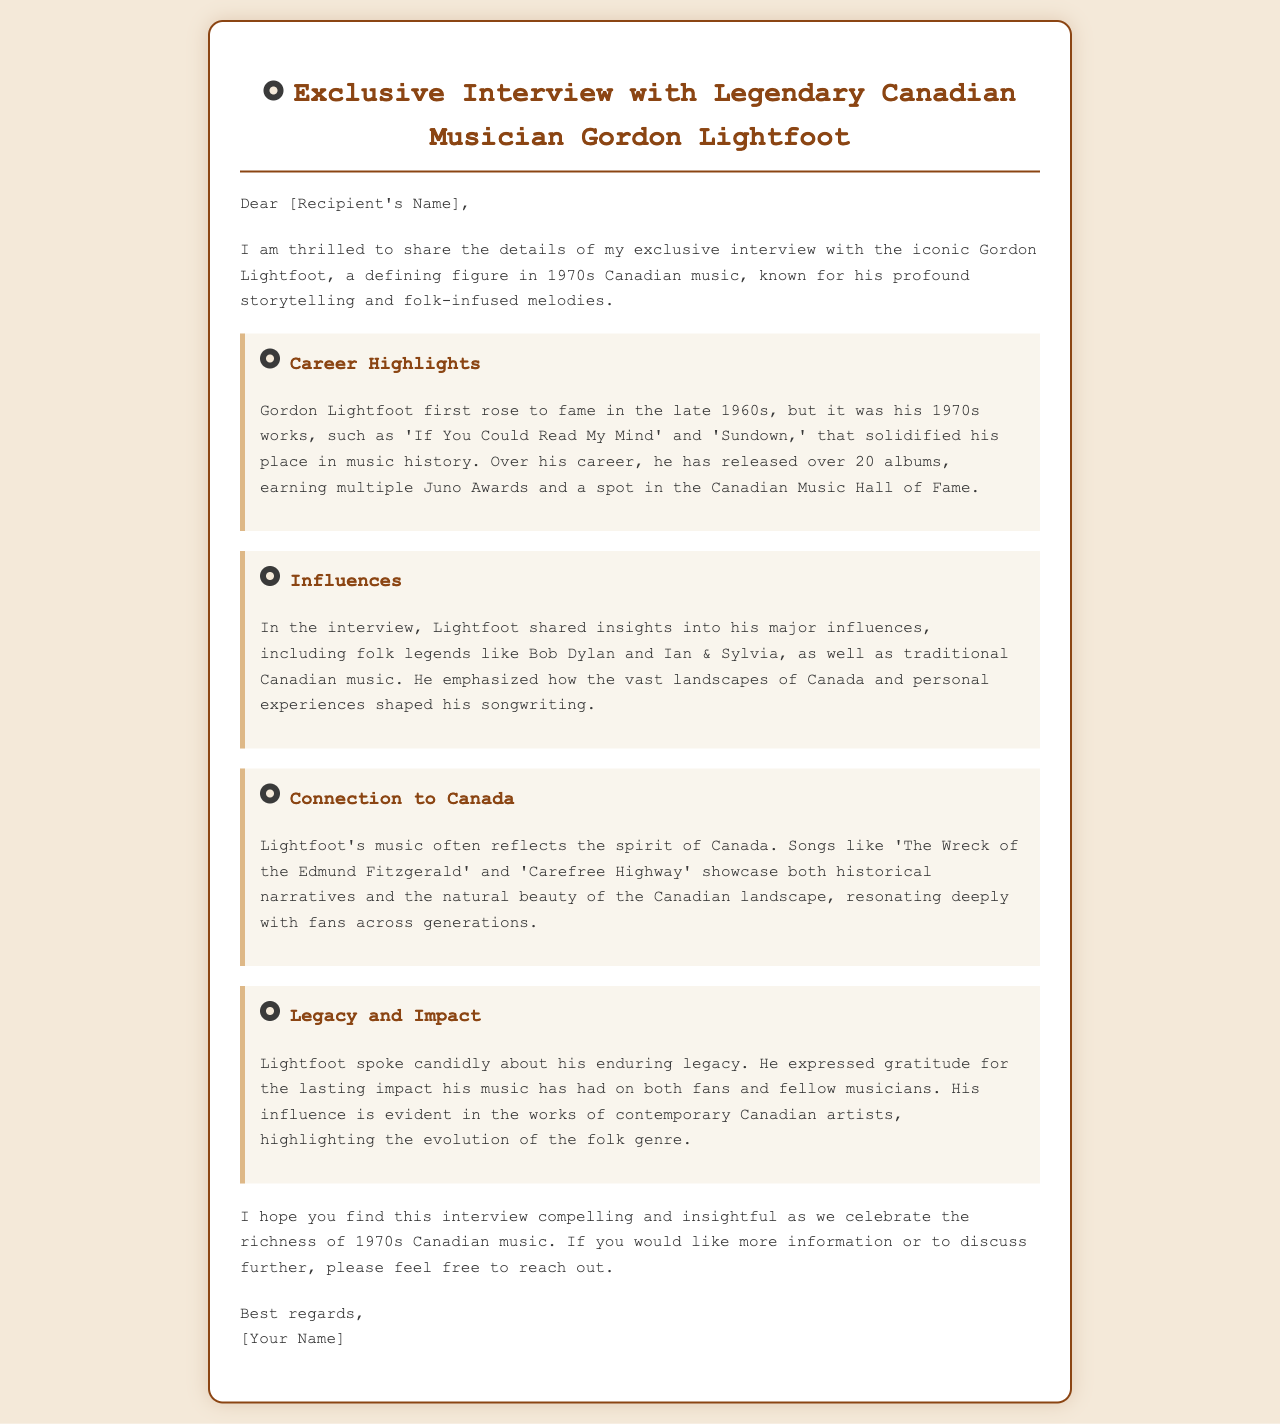What is the title of the email? The title is provided in the header of the email, introducing the subject of the interview.
Answer: Exclusive Interview with Legendary Canadian Musician Gordon Lightfoot Who is the musician featured in the interview? The document explicitly mentions the musician being interviewed, which is a key focus.
Answer: Gordon Lightfoot What significant song is mentioned that was released in the 1970s? The document lists specific songs associated with Lightfoot, showcasing his achievements during that time.
Answer: If You Could Read My Mind How many albums has Gordon Lightfoot released? The document states a specific quantity regarding the musician's discography.
Answer: Over 20 albums Which genre greatly influences Gordon Lightfoot's music? The document highlights the major influences on his music style, pinpointing a specific genre.
Answer: Folk What important aspect does Lightfoot say shapes his songwriting? The document mentions specific elements that significantly impact his songwriting process.
Answer: Personal experiences Which two artists did Lightfoot cite as his influences? The document references notable folk legends that have influenced the musician's work.
Answer: Bob Dylan and Ian & Sylvia What Canadian narrative is included in Lightfoot's music? The document describes a particular theme found in his notable songs, emphasizing his connection to Canada.
Answer: Historical narratives What is the email sender requesting from the recipient? The closing section of the email specifies what the sender is inviting or encouraging the recipient to do.
Answer: To reach out for more information or discussion 